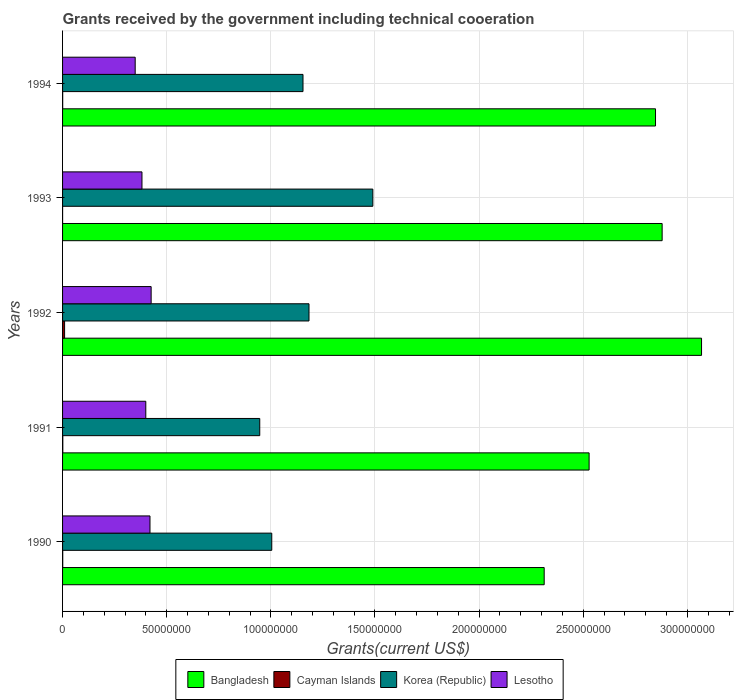Are the number of bars per tick equal to the number of legend labels?
Your response must be concise. Yes. Are the number of bars on each tick of the Y-axis equal?
Offer a terse response. Yes. How many bars are there on the 2nd tick from the bottom?
Give a very brief answer. 4. What is the label of the 3rd group of bars from the top?
Your response must be concise. 1992. What is the total grants received by the government in Korea (Republic) in 1990?
Give a very brief answer. 1.00e+08. Across all years, what is the maximum total grants received by the government in Korea (Republic)?
Keep it short and to the point. 1.49e+08. In which year was the total grants received by the government in Cayman Islands minimum?
Offer a terse response. 1993. What is the total total grants received by the government in Lesotho in the graph?
Ensure brevity in your answer.  1.97e+08. What is the difference between the total grants received by the government in Bangladesh in 1992 and that in 1993?
Give a very brief answer. 1.89e+07. What is the difference between the total grants received by the government in Lesotho in 1990 and the total grants received by the government in Cayman Islands in 1992?
Provide a succinct answer. 4.10e+07. What is the average total grants received by the government in Lesotho per year?
Ensure brevity in your answer.  3.95e+07. In the year 1990, what is the difference between the total grants received by the government in Korea (Republic) and total grants received by the government in Cayman Islands?
Make the answer very short. 1.00e+08. In how many years, is the total grants received by the government in Lesotho greater than 250000000 US$?
Provide a succinct answer. 0. What is the ratio of the total grants received by the government in Bangladesh in 1990 to that in 1992?
Make the answer very short. 0.75. Is the total grants received by the government in Cayman Islands in 1991 less than that in 1992?
Offer a terse response. Yes. What is the difference between the highest and the second highest total grants received by the government in Lesotho?
Your answer should be very brief. 5.60e+05. What is the difference between the highest and the lowest total grants received by the government in Bangladesh?
Your answer should be compact. 7.56e+07. What does the 2nd bar from the top in 1993 represents?
Your answer should be compact. Korea (Republic). What does the 4th bar from the bottom in 1991 represents?
Ensure brevity in your answer.  Lesotho. How many years are there in the graph?
Keep it short and to the point. 5. How are the legend labels stacked?
Provide a short and direct response. Horizontal. What is the title of the graph?
Your answer should be compact. Grants received by the government including technical cooeration. Does "Suriname" appear as one of the legend labels in the graph?
Provide a succinct answer. No. What is the label or title of the X-axis?
Your answer should be very brief. Grants(current US$). What is the label or title of the Y-axis?
Offer a terse response. Years. What is the Grants(current US$) in Bangladesh in 1990?
Your response must be concise. 2.31e+08. What is the Grants(current US$) in Korea (Republic) in 1990?
Offer a terse response. 1.00e+08. What is the Grants(current US$) of Lesotho in 1990?
Ensure brevity in your answer.  4.20e+07. What is the Grants(current US$) of Bangladesh in 1991?
Make the answer very short. 2.53e+08. What is the Grants(current US$) of Korea (Republic) in 1991?
Give a very brief answer. 9.47e+07. What is the Grants(current US$) in Lesotho in 1991?
Give a very brief answer. 4.00e+07. What is the Grants(current US$) of Bangladesh in 1992?
Keep it short and to the point. 3.07e+08. What is the Grants(current US$) in Cayman Islands in 1992?
Provide a short and direct response. 9.70e+05. What is the Grants(current US$) in Korea (Republic) in 1992?
Your answer should be very brief. 1.18e+08. What is the Grants(current US$) in Lesotho in 1992?
Give a very brief answer. 4.25e+07. What is the Grants(current US$) in Bangladesh in 1993?
Ensure brevity in your answer.  2.88e+08. What is the Grants(current US$) in Korea (Republic) in 1993?
Your answer should be very brief. 1.49e+08. What is the Grants(current US$) of Lesotho in 1993?
Make the answer very short. 3.81e+07. What is the Grants(current US$) of Bangladesh in 1994?
Offer a very short reply. 2.85e+08. What is the Grants(current US$) in Cayman Islands in 1994?
Your answer should be very brief. 6.00e+04. What is the Grants(current US$) of Korea (Republic) in 1994?
Make the answer very short. 1.15e+08. What is the Grants(current US$) of Lesotho in 1994?
Make the answer very short. 3.49e+07. Across all years, what is the maximum Grants(current US$) of Bangladesh?
Your answer should be very brief. 3.07e+08. Across all years, what is the maximum Grants(current US$) in Cayman Islands?
Your answer should be compact. 9.70e+05. Across all years, what is the maximum Grants(current US$) in Korea (Republic)?
Provide a short and direct response. 1.49e+08. Across all years, what is the maximum Grants(current US$) in Lesotho?
Make the answer very short. 4.25e+07. Across all years, what is the minimum Grants(current US$) in Bangladesh?
Ensure brevity in your answer.  2.31e+08. Across all years, what is the minimum Grants(current US$) in Cayman Islands?
Your response must be concise. 10000. Across all years, what is the minimum Grants(current US$) in Korea (Republic)?
Provide a succinct answer. 9.47e+07. Across all years, what is the minimum Grants(current US$) of Lesotho?
Offer a very short reply. 3.49e+07. What is the total Grants(current US$) in Bangladesh in the graph?
Provide a short and direct response. 1.36e+09. What is the total Grants(current US$) of Cayman Islands in the graph?
Offer a terse response. 1.24e+06. What is the total Grants(current US$) of Korea (Republic) in the graph?
Your response must be concise. 5.78e+08. What is the total Grants(current US$) of Lesotho in the graph?
Provide a short and direct response. 1.97e+08. What is the difference between the Grants(current US$) of Bangladesh in 1990 and that in 1991?
Offer a terse response. -2.16e+07. What is the difference between the Grants(current US$) in Cayman Islands in 1990 and that in 1991?
Offer a terse response. -4.00e+04. What is the difference between the Grants(current US$) of Korea (Republic) in 1990 and that in 1991?
Offer a very short reply. 5.77e+06. What is the difference between the Grants(current US$) in Lesotho in 1990 and that in 1991?
Your answer should be very brief. 2.01e+06. What is the difference between the Grants(current US$) of Bangladesh in 1990 and that in 1992?
Your response must be concise. -7.56e+07. What is the difference between the Grants(current US$) of Cayman Islands in 1990 and that in 1992?
Offer a very short reply. -8.90e+05. What is the difference between the Grants(current US$) in Korea (Republic) in 1990 and that in 1992?
Your answer should be compact. -1.79e+07. What is the difference between the Grants(current US$) in Lesotho in 1990 and that in 1992?
Your answer should be very brief. -5.60e+05. What is the difference between the Grants(current US$) in Bangladesh in 1990 and that in 1993?
Provide a short and direct response. -5.66e+07. What is the difference between the Grants(current US$) of Korea (Republic) in 1990 and that in 1993?
Your answer should be compact. -4.85e+07. What is the difference between the Grants(current US$) of Lesotho in 1990 and that in 1993?
Ensure brevity in your answer.  3.85e+06. What is the difference between the Grants(current US$) in Bangladesh in 1990 and that in 1994?
Keep it short and to the point. -5.34e+07. What is the difference between the Grants(current US$) of Cayman Islands in 1990 and that in 1994?
Your response must be concise. 2.00e+04. What is the difference between the Grants(current US$) of Korea (Republic) in 1990 and that in 1994?
Keep it short and to the point. -1.50e+07. What is the difference between the Grants(current US$) of Lesotho in 1990 and that in 1994?
Offer a very short reply. 7.10e+06. What is the difference between the Grants(current US$) of Bangladesh in 1991 and that in 1992?
Give a very brief answer. -5.40e+07. What is the difference between the Grants(current US$) of Cayman Islands in 1991 and that in 1992?
Keep it short and to the point. -8.50e+05. What is the difference between the Grants(current US$) of Korea (Republic) in 1991 and that in 1992?
Provide a succinct answer. -2.36e+07. What is the difference between the Grants(current US$) of Lesotho in 1991 and that in 1992?
Ensure brevity in your answer.  -2.57e+06. What is the difference between the Grants(current US$) in Bangladesh in 1991 and that in 1993?
Provide a short and direct response. -3.51e+07. What is the difference between the Grants(current US$) of Korea (Republic) in 1991 and that in 1993?
Ensure brevity in your answer.  -5.43e+07. What is the difference between the Grants(current US$) in Lesotho in 1991 and that in 1993?
Your answer should be compact. 1.84e+06. What is the difference between the Grants(current US$) of Bangladesh in 1991 and that in 1994?
Offer a very short reply. -3.19e+07. What is the difference between the Grants(current US$) of Cayman Islands in 1991 and that in 1994?
Offer a very short reply. 6.00e+04. What is the difference between the Grants(current US$) in Korea (Republic) in 1991 and that in 1994?
Provide a succinct answer. -2.08e+07. What is the difference between the Grants(current US$) in Lesotho in 1991 and that in 1994?
Your response must be concise. 5.09e+06. What is the difference between the Grants(current US$) of Bangladesh in 1992 and that in 1993?
Your response must be concise. 1.89e+07. What is the difference between the Grants(current US$) in Cayman Islands in 1992 and that in 1993?
Offer a very short reply. 9.60e+05. What is the difference between the Grants(current US$) of Korea (Republic) in 1992 and that in 1993?
Your response must be concise. -3.06e+07. What is the difference between the Grants(current US$) of Lesotho in 1992 and that in 1993?
Keep it short and to the point. 4.41e+06. What is the difference between the Grants(current US$) in Bangladesh in 1992 and that in 1994?
Give a very brief answer. 2.21e+07. What is the difference between the Grants(current US$) of Cayman Islands in 1992 and that in 1994?
Provide a succinct answer. 9.10e+05. What is the difference between the Grants(current US$) in Korea (Republic) in 1992 and that in 1994?
Your answer should be very brief. 2.88e+06. What is the difference between the Grants(current US$) in Lesotho in 1992 and that in 1994?
Give a very brief answer. 7.66e+06. What is the difference between the Grants(current US$) in Bangladesh in 1993 and that in 1994?
Provide a short and direct response. 3.18e+06. What is the difference between the Grants(current US$) of Korea (Republic) in 1993 and that in 1994?
Offer a terse response. 3.35e+07. What is the difference between the Grants(current US$) of Lesotho in 1993 and that in 1994?
Offer a very short reply. 3.25e+06. What is the difference between the Grants(current US$) of Bangladesh in 1990 and the Grants(current US$) of Cayman Islands in 1991?
Make the answer very short. 2.31e+08. What is the difference between the Grants(current US$) in Bangladesh in 1990 and the Grants(current US$) in Korea (Republic) in 1991?
Ensure brevity in your answer.  1.37e+08. What is the difference between the Grants(current US$) of Bangladesh in 1990 and the Grants(current US$) of Lesotho in 1991?
Provide a succinct answer. 1.91e+08. What is the difference between the Grants(current US$) of Cayman Islands in 1990 and the Grants(current US$) of Korea (Republic) in 1991?
Provide a short and direct response. -9.46e+07. What is the difference between the Grants(current US$) of Cayman Islands in 1990 and the Grants(current US$) of Lesotho in 1991?
Offer a very short reply. -3.99e+07. What is the difference between the Grants(current US$) in Korea (Republic) in 1990 and the Grants(current US$) in Lesotho in 1991?
Offer a very short reply. 6.05e+07. What is the difference between the Grants(current US$) in Bangladesh in 1990 and the Grants(current US$) in Cayman Islands in 1992?
Keep it short and to the point. 2.30e+08. What is the difference between the Grants(current US$) of Bangladesh in 1990 and the Grants(current US$) of Korea (Republic) in 1992?
Provide a short and direct response. 1.13e+08. What is the difference between the Grants(current US$) of Bangladesh in 1990 and the Grants(current US$) of Lesotho in 1992?
Offer a very short reply. 1.89e+08. What is the difference between the Grants(current US$) in Cayman Islands in 1990 and the Grants(current US$) in Korea (Republic) in 1992?
Ensure brevity in your answer.  -1.18e+08. What is the difference between the Grants(current US$) of Cayman Islands in 1990 and the Grants(current US$) of Lesotho in 1992?
Your answer should be very brief. -4.24e+07. What is the difference between the Grants(current US$) of Korea (Republic) in 1990 and the Grants(current US$) of Lesotho in 1992?
Keep it short and to the point. 5.79e+07. What is the difference between the Grants(current US$) of Bangladesh in 1990 and the Grants(current US$) of Cayman Islands in 1993?
Offer a terse response. 2.31e+08. What is the difference between the Grants(current US$) in Bangladesh in 1990 and the Grants(current US$) in Korea (Republic) in 1993?
Make the answer very short. 8.23e+07. What is the difference between the Grants(current US$) of Bangladesh in 1990 and the Grants(current US$) of Lesotho in 1993?
Provide a short and direct response. 1.93e+08. What is the difference between the Grants(current US$) in Cayman Islands in 1990 and the Grants(current US$) in Korea (Republic) in 1993?
Offer a terse response. -1.49e+08. What is the difference between the Grants(current US$) in Cayman Islands in 1990 and the Grants(current US$) in Lesotho in 1993?
Offer a very short reply. -3.80e+07. What is the difference between the Grants(current US$) in Korea (Republic) in 1990 and the Grants(current US$) in Lesotho in 1993?
Give a very brief answer. 6.23e+07. What is the difference between the Grants(current US$) in Bangladesh in 1990 and the Grants(current US$) in Cayman Islands in 1994?
Give a very brief answer. 2.31e+08. What is the difference between the Grants(current US$) in Bangladesh in 1990 and the Grants(current US$) in Korea (Republic) in 1994?
Keep it short and to the point. 1.16e+08. What is the difference between the Grants(current US$) in Bangladesh in 1990 and the Grants(current US$) in Lesotho in 1994?
Give a very brief answer. 1.96e+08. What is the difference between the Grants(current US$) of Cayman Islands in 1990 and the Grants(current US$) of Korea (Republic) in 1994?
Keep it short and to the point. -1.15e+08. What is the difference between the Grants(current US$) of Cayman Islands in 1990 and the Grants(current US$) of Lesotho in 1994?
Your answer should be very brief. -3.48e+07. What is the difference between the Grants(current US$) of Korea (Republic) in 1990 and the Grants(current US$) of Lesotho in 1994?
Make the answer very short. 6.56e+07. What is the difference between the Grants(current US$) of Bangladesh in 1991 and the Grants(current US$) of Cayman Islands in 1992?
Make the answer very short. 2.52e+08. What is the difference between the Grants(current US$) of Bangladesh in 1991 and the Grants(current US$) of Korea (Republic) in 1992?
Keep it short and to the point. 1.34e+08. What is the difference between the Grants(current US$) of Bangladesh in 1991 and the Grants(current US$) of Lesotho in 1992?
Give a very brief answer. 2.10e+08. What is the difference between the Grants(current US$) in Cayman Islands in 1991 and the Grants(current US$) in Korea (Republic) in 1992?
Ensure brevity in your answer.  -1.18e+08. What is the difference between the Grants(current US$) of Cayman Islands in 1991 and the Grants(current US$) of Lesotho in 1992?
Offer a terse response. -4.24e+07. What is the difference between the Grants(current US$) in Korea (Republic) in 1991 and the Grants(current US$) in Lesotho in 1992?
Offer a very short reply. 5.21e+07. What is the difference between the Grants(current US$) in Bangladesh in 1991 and the Grants(current US$) in Cayman Islands in 1993?
Your answer should be very brief. 2.53e+08. What is the difference between the Grants(current US$) in Bangladesh in 1991 and the Grants(current US$) in Korea (Republic) in 1993?
Ensure brevity in your answer.  1.04e+08. What is the difference between the Grants(current US$) in Bangladesh in 1991 and the Grants(current US$) in Lesotho in 1993?
Your answer should be very brief. 2.15e+08. What is the difference between the Grants(current US$) of Cayman Islands in 1991 and the Grants(current US$) of Korea (Republic) in 1993?
Provide a succinct answer. -1.49e+08. What is the difference between the Grants(current US$) of Cayman Islands in 1991 and the Grants(current US$) of Lesotho in 1993?
Offer a very short reply. -3.80e+07. What is the difference between the Grants(current US$) of Korea (Republic) in 1991 and the Grants(current US$) of Lesotho in 1993?
Keep it short and to the point. 5.66e+07. What is the difference between the Grants(current US$) of Bangladesh in 1991 and the Grants(current US$) of Cayman Islands in 1994?
Ensure brevity in your answer.  2.53e+08. What is the difference between the Grants(current US$) of Bangladesh in 1991 and the Grants(current US$) of Korea (Republic) in 1994?
Your response must be concise. 1.37e+08. What is the difference between the Grants(current US$) in Bangladesh in 1991 and the Grants(current US$) in Lesotho in 1994?
Ensure brevity in your answer.  2.18e+08. What is the difference between the Grants(current US$) of Cayman Islands in 1991 and the Grants(current US$) of Korea (Republic) in 1994?
Make the answer very short. -1.15e+08. What is the difference between the Grants(current US$) in Cayman Islands in 1991 and the Grants(current US$) in Lesotho in 1994?
Your answer should be compact. -3.48e+07. What is the difference between the Grants(current US$) in Korea (Republic) in 1991 and the Grants(current US$) in Lesotho in 1994?
Keep it short and to the point. 5.98e+07. What is the difference between the Grants(current US$) of Bangladesh in 1992 and the Grants(current US$) of Cayman Islands in 1993?
Make the answer very short. 3.07e+08. What is the difference between the Grants(current US$) of Bangladesh in 1992 and the Grants(current US$) of Korea (Republic) in 1993?
Give a very brief answer. 1.58e+08. What is the difference between the Grants(current US$) in Bangladesh in 1992 and the Grants(current US$) in Lesotho in 1993?
Provide a succinct answer. 2.69e+08. What is the difference between the Grants(current US$) in Cayman Islands in 1992 and the Grants(current US$) in Korea (Republic) in 1993?
Make the answer very short. -1.48e+08. What is the difference between the Grants(current US$) of Cayman Islands in 1992 and the Grants(current US$) of Lesotho in 1993?
Ensure brevity in your answer.  -3.72e+07. What is the difference between the Grants(current US$) of Korea (Republic) in 1992 and the Grants(current US$) of Lesotho in 1993?
Provide a succinct answer. 8.02e+07. What is the difference between the Grants(current US$) in Bangladesh in 1992 and the Grants(current US$) in Cayman Islands in 1994?
Offer a very short reply. 3.07e+08. What is the difference between the Grants(current US$) of Bangladesh in 1992 and the Grants(current US$) of Korea (Republic) in 1994?
Your response must be concise. 1.91e+08. What is the difference between the Grants(current US$) of Bangladesh in 1992 and the Grants(current US$) of Lesotho in 1994?
Offer a very short reply. 2.72e+08. What is the difference between the Grants(current US$) of Cayman Islands in 1992 and the Grants(current US$) of Korea (Republic) in 1994?
Offer a terse response. -1.14e+08. What is the difference between the Grants(current US$) of Cayman Islands in 1992 and the Grants(current US$) of Lesotho in 1994?
Offer a very short reply. -3.39e+07. What is the difference between the Grants(current US$) of Korea (Republic) in 1992 and the Grants(current US$) of Lesotho in 1994?
Provide a succinct answer. 8.34e+07. What is the difference between the Grants(current US$) in Bangladesh in 1993 and the Grants(current US$) in Cayman Islands in 1994?
Provide a succinct answer. 2.88e+08. What is the difference between the Grants(current US$) of Bangladesh in 1993 and the Grants(current US$) of Korea (Republic) in 1994?
Make the answer very short. 1.72e+08. What is the difference between the Grants(current US$) of Bangladesh in 1993 and the Grants(current US$) of Lesotho in 1994?
Provide a succinct answer. 2.53e+08. What is the difference between the Grants(current US$) of Cayman Islands in 1993 and the Grants(current US$) of Korea (Republic) in 1994?
Provide a short and direct response. -1.15e+08. What is the difference between the Grants(current US$) in Cayman Islands in 1993 and the Grants(current US$) in Lesotho in 1994?
Provide a short and direct response. -3.49e+07. What is the difference between the Grants(current US$) of Korea (Republic) in 1993 and the Grants(current US$) of Lesotho in 1994?
Your answer should be very brief. 1.14e+08. What is the average Grants(current US$) of Bangladesh per year?
Offer a terse response. 2.73e+08. What is the average Grants(current US$) of Cayman Islands per year?
Your answer should be very brief. 2.48e+05. What is the average Grants(current US$) of Korea (Republic) per year?
Provide a short and direct response. 1.16e+08. What is the average Grants(current US$) of Lesotho per year?
Offer a very short reply. 3.95e+07. In the year 1990, what is the difference between the Grants(current US$) of Bangladesh and Grants(current US$) of Cayman Islands?
Make the answer very short. 2.31e+08. In the year 1990, what is the difference between the Grants(current US$) of Bangladesh and Grants(current US$) of Korea (Republic)?
Keep it short and to the point. 1.31e+08. In the year 1990, what is the difference between the Grants(current US$) in Bangladesh and Grants(current US$) in Lesotho?
Offer a terse response. 1.89e+08. In the year 1990, what is the difference between the Grants(current US$) of Cayman Islands and Grants(current US$) of Korea (Republic)?
Offer a terse response. -1.00e+08. In the year 1990, what is the difference between the Grants(current US$) in Cayman Islands and Grants(current US$) in Lesotho?
Offer a terse response. -4.19e+07. In the year 1990, what is the difference between the Grants(current US$) of Korea (Republic) and Grants(current US$) of Lesotho?
Give a very brief answer. 5.85e+07. In the year 1991, what is the difference between the Grants(current US$) in Bangladesh and Grants(current US$) in Cayman Islands?
Give a very brief answer. 2.53e+08. In the year 1991, what is the difference between the Grants(current US$) of Bangladesh and Grants(current US$) of Korea (Republic)?
Offer a terse response. 1.58e+08. In the year 1991, what is the difference between the Grants(current US$) of Bangladesh and Grants(current US$) of Lesotho?
Your answer should be very brief. 2.13e+08. In the year 1991, what is the difference between the Grants(current US$) of Cayman Islands and Grants(current US$) of Korea (Republic)?
Provide a short and direct response. -9.46e+07. In the year 1991, what is the difference between the Grants(current US$) in Cayman Islands and Grants(current US$) in Lesotho?
Provide a succinct answer. -3.98e+07. In the year 1991, what is the difference between the Grants(current US$) in Korea (Republic) and Grants(current US$) in Lesotho?
Ensure brevity in your answer.  5.47e+07. In the year 1992, what is the difference between the Grants(current US$) of Bangladesh and Grants(current US$) of Cayman Islands?
Make the answer very short. 3.06e+08. In the year 1992, what is the difference between the Grants(current US$) of Bangladesh and Grants(current US$) of Korea (Republic)?
Make the answer very short. 1.88e+08. In the year 1992, what is the difference between the Grants(current US$) in Bangladesh and Grants(current US$) in Lesotho?
Keep it short and to the point. 2.64e+08. In the year 1992, what is the difference between the Grants(current US$) of Cayman Islands and Grants(current US$) of Korea (Republic)?
Give a very brief answer. -1.17e+08. In the year 1992, what is the difference between the Grants(current US$) of Cayman Islands and Grants(current US$) of Lesotho?
Your answer should be very brief. -4.16e+07. In the year 1992, what is the difference between the Grants(current US$) of Korea (Republic) and Grants(current US$) of Lesotho?
Offer a terse response. 7.58e+07. In the year 1993, what is the difference between the Grants(current US$) of Bangladesh and Grants(current US$) of Cayman Islands?
Make the answer very short. 2.88e+08. In the year 1993, what is the difference between the Grants(current US$) of Bangladesh and Grants(current US$) of Korea (Republic)?
Ensure brevity in your answer.  1.39e+08. In the year 1993, what is the difference between the Grants(current US$) of Bangladesh and Grants(current US$) of Lesotho?
Your answer should be compact. 2.50e+08. In the year 1993, what is the difference between the Grants(current US$) of Cayman Islands and Grants(current US$) of Korea (Republic)?
Ensure brevity in your answer.  -1.49e+08. In the year 1993, what is the difference between the Grants(current US$) of Cayman Islands and Grants(current US$) of Lesotho?
Your response must be concise. -3.81e+07. In the year 1993, what is the difference between the Grants(current US$) in Korea (Republic) and Grants(current US$) in Lesotho?
Ensure brevity in your answer.  1.11e+08. In the year 1994, what is the difference between the Grants(current US$) of Bangladesh and Grants(current US$) of Cayman Islands?
Provide a succinct answer. 2.85e+08. In the year 1994, what is the difference between the Grants(current US$) of Bangladesh and Grants(current US$) of Korea (Republic)?
Your answer should be very brief. 1.69e+08. In the year 1994, what is the difference between the Grants(current US$) of Bangladesh and Grants(current US$) of Lesotho?
Your response must be concise. 2.50e+08. In the year 1994, what is the difference between the Grants(current US$) in Cayman Islands and Grants(current US$) in Korea (Republic)?
Ensure brevity in your answer.  -1.15e+08. In the year 1994, what is the difference between the Grants(current US$) of Cayman Islands and Grants(current US$) of Lesotho?
Make the answer very short. -3.48e+07. In the year 1994, what is the difference between the Grants(current US$) of Korea (Republic) and Grants(current US$) of Lesotho?
Ensure brevity in your answer.  8.06e+07. What is the ratio of the Grants(current US$) of Bangladesh in 1990 to that in 1991?
Provide a succinct answer. 0.91. What is the ratio of the Grants(current US$) of Korea (Republic) in 1990 to that in 1991?
Offer a terse response. 1.06. What is the ratio of the Grants(current US$) of Lesotho in 1990 to that in 1991?
Keep it short and to the point. 1.05. What is the ratio of the Grants(current US$) in Bangladesh in 1990 to that in 1992?
Give a very brief answer. 0.75. What is the ratio of the Grants(current US$) of Cayman Islands in 1990 to that in 1992?
Provide a succinct answer. 0.08. What is the ratio of the Grants(current US$) of Korea (Republic) in 1990 to that in 1992?
Provide a short and direct response. 0.85. What is the ratio of the Grants(current US$) of Bangladesh in 1990 to that in 1993?
Your answer should be compact. 0.8. What is the ratio of the Grants(current US$) of Korea (Republic) in 1990 to that in 1993?
Provide a short and direct response. 0.67. What is the ratio of the Grants(current US$) in Lesotho in 1990 to that in 1993?
Offer a terse response. 1.1. What is the ratio of the Grants(current US$) of Bangladesh in 1990 to that in 1994?
Provide a succinct answer. 0.81. What is the ratio of the Grants(current US$) in Korea (Republic) in 1990 to that in 1994?
Offer a very short reply. 0.87. What is the ratio of the Grants(current US$) of Lesotho in 1990 to that in 1994?
Ensure brevity in your answer.  1.2. What is the ratio of the Grants(current US$) in Bangladesh in 1991 to that in 1992?
Your answer should be very brief. 0.82. What is the ratio of the Grants(current US$) of Cayman Islands in 1991 to that in 1992?
Give a very brief answer. 0.12. What is the ratio of the Grants(current US$) in Korea (Republic) in 1991 to that in 1992?
Your answer should be very brief. 0.8. What is the ratio of the Grants(current US$) in Lesotho in 1991 to that in 1992?
Your answer should be very brief. 0.94. What is the ratio of the Grants(current US$) of Bangladesh in 1991 to that in 1993?
Your answer should be compact. 0.88. What is the ratio of the Grants(current US$) of Korea (Republic) in 1991 to that in 1993?
Your answer should be compact. 0.64. What is the ratio of the Grants(current US$) in Lesotho in 1991 to that in 1993?
Your answer should be very brief. 1.05. What is the ratio of the Grants(current US$) of Bangladesh in 1991 to that in 1994?
Your answer should be compact. 0.89. What is the ratio of the Grants(current US$) of Cayman Islands in 1991 to that in 1994?
Ensure brevity in your answer.  2. What is the ratio of the Grants(current US$) of Korea (Republic) in 1991 to that in 1994?
Offer a terse response. 0.82. What is the ratio of the Grants(current US$) in Lesotho in 1991 to that in 1994?
Your answer should be very brief. 1.15. What is the ratio of the Grants(current US$) of Bangladesh in 1992 to that in 1993?
Provide a succinct answer. 1.07. What is the ratio of the Grants(current US$) of Cayman Islands in 1992 to that in 1993?
Give a very brief answer. 97. What is the ratio of the Grants(current US$) of Korea (Republic) in 1992 to that in 1993?
Ensure brevity in your answer.  0.79. What is the ratio of the Grants(current US$) of Lesotho in 1992 to that in 1993?
Your answer should be very brief. 1.12. What is the ratio of the Grants(current US$) in Bangladesh in 1992 to that in 1994?
Give a very brief answer. 1.08. What is the ratio of the Grants(current US$) of Cayman Islands in 1992 to that in 1994?
Your response must be concise. 16.17. What is the ratio of the Grants(current US$) in Korea (Republic) in 1992 to that in 1994?
Provide a short and direct response. 1.02. What is the ratio of the Grants(current US$) in Lesotho in 1992 to that in 1994?
Provide a succinct answer. 1.22. What is the ratio of the Grants(current US$) of Bangladesh in 1993 to that in 1994?
Your response must be concise. 1.01. What is the ratio of the Grants(current US$) in Korea (Republic) in 1993 to that in 1994?
Provide a short and direct response. 1.29. What is the ratio of the Grants(current US$) in Lesotho in 1993 to that in 1994?
Offer a very short reply. 1.09. What is the difference between the highest and the second highest Grants(current US$) of Bangladesh?
Your answer should be compact. 1.89e+07. What is the difference between the highest and the second highest Grants(current US$) in Cayman Islands?
Offer a terse response. 8.50e+05. What is the difference between the highest and the second highest Grants(current US$) in Korea (Republic)?
Keep it short and to the point. 3.06e+07. What is the difference between the highest and the second highest Grants(current US$) in Lesotho?
Your answer should be very brief. 5.60e+05. What is the difference between the highest and the lowest Grants(current US$) of Bangladesh?
Offer a very short reply. 7.56e+07. What is the difference between the highest and the lowest Grants(current US$) in Cayman Islands?
Provide a short and direct response. 9.60e+05. What is the difference between the highest and the lowest Grants(current US$) of Korea (Republic)?
Provide a succinct answer. 5.43e+07. What is the difference between the highest and the lowest Grants(current US$) in Lesotho?
Offer a terse response. 7.66e+06. 